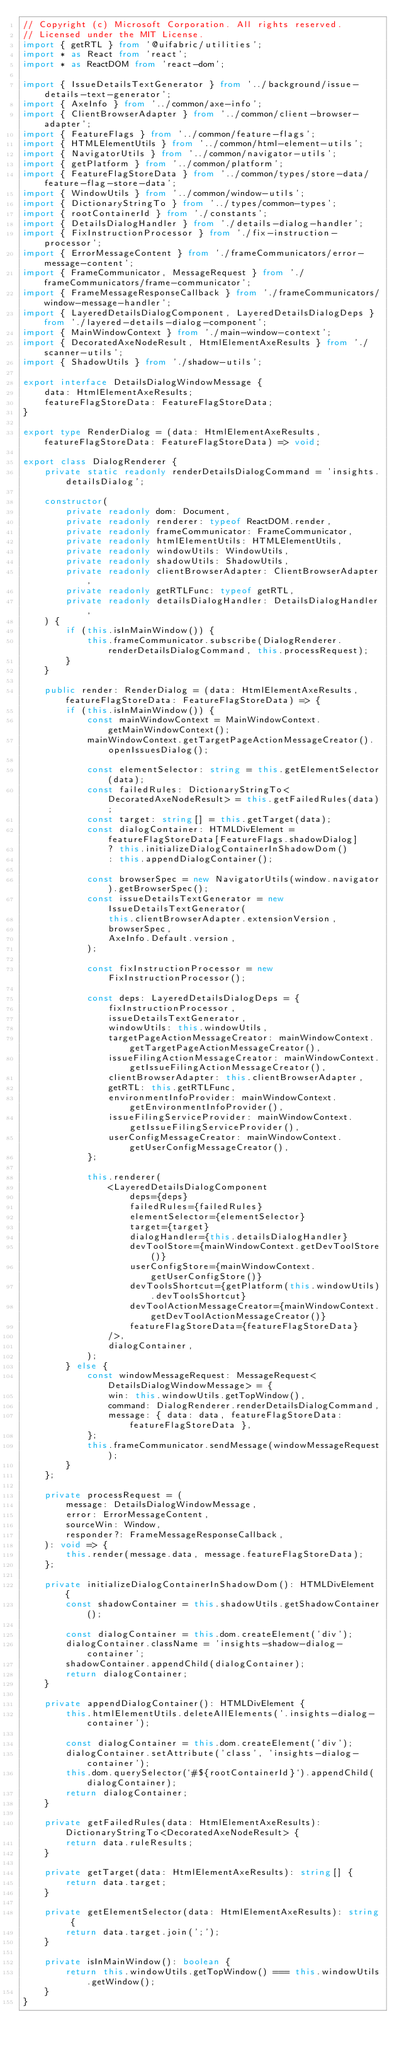Convert code to text. <code><loc_0><loc_0><loc_500><loc_500><_TypeScript_>// Copyright (c) Microsoft Corporation. All rights reserved.
// Licensed under the MIT License.
import { getRTL } from '@uifabric/utilities';
import * as React from 'react';
import * as ReactDOM from 'react-dom';

import { IssueDetailsTextGenerator } from '../background/issue-details-text-generator';
import { AxeInfo } from '../common/axe-info';
import { ClientBrowserAdapter } from '../common/client-browser-adapter';
import { FeatureFlags } from '../common/feature-flags';
import { HTMLElementUtils } from '../common/html-element-utils';
import { NavigatorUtils } from '../common/navigator-utils';
import { getPlatform } from '../common/platform';
import { FeatureFlagStoreData } from '../common/types/store-data/feature-flag-store-data';
import { WindowUtils } from '../common/window-utils';
import { DictionaryStringTo } from '../types/common-types';
import { rootContainerId } from './constants';
import { DetailsDialogHandler } from './details-dialog-handler';
import { FixInstructionProcessor } from './fix-instruction-processor';
import { ErrorMessageContent } from './frameCommunicators/error-message-content';
import { FrameCommunicator, MessageRequest } from './frameCommunicators/frame-communicator';
import { FrameMessageResponseCallback } from './frameCommunicators/window-message-handler';
import { LayeredDetailsDialogComponent, LayeredDetailsDialogDeps } from './layered-details-dialog-component';
import { MainWindowContext } from './main-window-context';
import { DecoratedAxeNodeResult, HtmlElementAxeResults } from './scanner-utils';
import { ShadowUtils } from './shadow-utils';

export interface DetailsDialogWindowMessage {
    data: HtmlElementAxeResults;
    featureFlagStoreData: FeatureFlagStoreData;
}

export type RenderDialog = (data: HtmlElementAxeResults, featureFlagStoreData: FeatureFlagStoreData) => void;

export class DialogRenderer {
    private static readonly renderDetailsDialogCommand = 'insights.detailsDialog';

    constructor(
        private readonly dom: Document,
        private readonly renderer: typeof ReactDOM.render,
        private readonly frameCommunicator: FrameCommunicator,
        private readonly htmlElementUtils: HTMLElementUtils,
        private readonly windowUtils: WindowUtils,
        private readonly shadowUtils: ShadowUtils,
        private readonly clientBrowserAdapter: ClientBrowserAdapter,
        private readonly getRTLFunc: typeof getRTL,
        private readonly detailsDialogHandler: DetailsDialogHandler,
    ) {
        if (this.isInMainWindow()) {
            this.frameCommunicator.subscribe(DialogRenderer.renderDetailsDialogCommand, this.processRequest);
        }
    }

    public render: RenderDialog = (data: HtmlElementAxeResults, featureFlagStoreData: FeatureFlagStoreData) => {
        if (this.isInMainWindow()) {
            const mainWindowContext = MainWindowContext.getMainWindowContext();
            mainWindowContext.getTargetPageActionMessageCreator().openIssuesDialog();

            const elementSelector: string = this.getElementSelector(data);
            const failedRules: DictionaryStringTo<DecoratedAxeNodeResult> = this.getFailedRules(data);
            const target: string[] = this.getTarget(data);
            const dialogContainer: HTMLDivElement = featureFlagStoreData[FeatureFlags.shadowDialog]
                ? this.initializeDialogContainerInShadowDom()
                : this.appendDialogContainer();

            const browserSpec = new NavigatorUtils(window.navigator).getBrowserSpec();
            const issueDetailsTextGenerator = new IssueDetailsTextGenerator(
                this.clientBrowserAdapter.extensionVersion,
                browserSpec,
                AxeInfo.Default.version,
            );

            const fixInstructionProcessor = new FixInstructionProcessor();

            const deps: LayeredDetailsDialogDeps = {
                fixInstructionProcessor,
                issueDetailsTextGenerator,
                windowUtils: this.windowUtils,
                targetPageActionMessageCreator: mainWindowContext.getTargetPageActionMessageCreator(),
                issueFilingActionMessageCreator: mainWindowContext.getIssueFilingActionMessageCreator(),
                clientBrowserAdapter: this.clientBrowserAdapter,
                getRTL: this.getRTLFunc,
                environmentInfoProvider: mainWindowContext.getEnvironmentInfoProvider(),
                issueFilingServiceProvider: mainWindowContext.getIssueFilingServiceProvider(),
                userConfigMessageCreator: mainWindowContext.getUserConfigMessageCreator(),
            };

            this.renderer(
                <LayeredDetailsDialogComponent
                    deps={deps}
                    failedRules={failedRules}
                    elementSelector={elementSelector}
                    target={target}
                    dialogHandler={this.detailsDialogHandler}
                    devToolStore={mainWindowContext.getDevToolStore()}
                    userConfigStore={mainWindowContext.getUserConfigStore()}
                    devToolsShortcut={getPlatform(this.windowUtils).devToolsShortcut}
                    devToolActionMessageCreator={mainWindowContext.getDevToolActionMessageCreator()}
                    featureFlagStoreData={featureFlagStoreData}
                />,
                dialogContainer,
            );
        } else {
            const windowMessageRequest: MessageRequest<DetailsDialogWindowMessage> = {
                win: this.windowUtils.getTopWindow(),
                command: DialogRenderer.renderDetailsDialogCommand,
                message: { data: data, featureFlagStoreData: featureFlagStoreData },
            };
            this.frameCommunicator.sendMessage(windowMessageRequest);
        }
    };

    private processRequest = (
        message: DetailsDialogWindowMessage,
        error: ErrorMessageContent,
        sourceWin: Window,
        responder?: FrameMessageResponseCallback,
    ): void => {
        this.render(message.data, message.featureFlagStoreData);
    };

    private initializeDialogContainerInShadowDom(): HTMLDivElement {
        const shadowContainer = this.shadowUtils.getShadowContainer();

        const dialogContainer = this.dom.createElement('div');
        dialogContainer.className = 'insights-shadow-dialog-container';
        shadowContainer.appendChild(dialogContainer);
        return dialogContainer;
    }

    private appendDialogContainer(): HTMLDivElement {
        this.htmlElementUtils.deleteAllElements('.insights-dialog-container');

        const dialogContainer = this.dom.createElement('div');
        dialogContainer.setAttribute('class', 'insights-dialog-container');
        this.dom.querySelector(`#${rootContainerId}`).appendChild(dialogContainer);
        return dialogContainer;
    }

    private getFailedRules(data: HtmlElementAxeResults): DictionaryStringTo<DecoratedAxeNodeResult> {
        return data.ruleResults;
    }

    private getTarget(data: HtmlElementAxeResults): string[] {
        return data.target;
    }

    private getElementSelector(data: HtmlElementAxeResults): string {
        return data.target.join(';');
    }

    private isInMainWindow(): boolean {
        return this.windowUtils.getTopWindow() === this.windowUtils.getWindow();
    }
}
</code> 